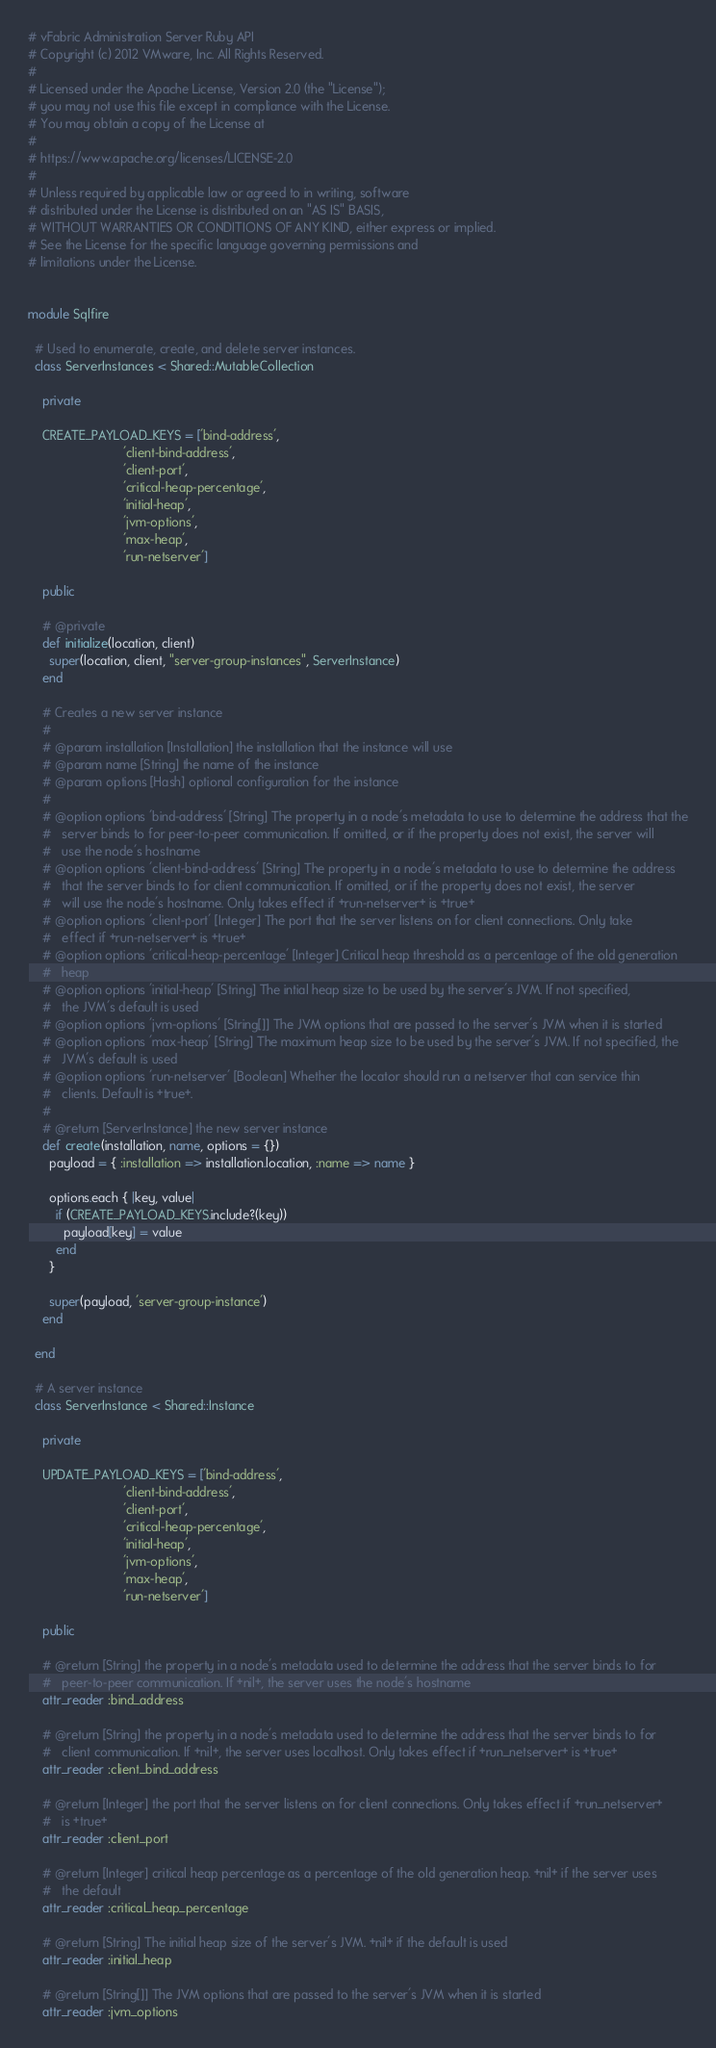<code> <loc_0><loc_0><loc_500><loc_500><_Ruby_># vFabric Administration Server Ruby API
# Copyright (c) 2012 VMware, Inc. All Rights Reserved.
#
# Licensed under the Apache License, Version 2.0 (the "License");
# you may not use this file except in compliance with the License.
# You may obtain a copy of the License at
#
# https://www.apache.org/licenses/LICENSE-2.0
#
# Unless required by applicable law or agreed to in writing, software
# distributed under the License is distributed on an "AS IS" BASIS,
# WITHOUT WARRANTIES OR CONDITIONS OF ANY KIND, either express or implied.
# See the License for the specific language governing permissions and
# limitations under the License.


module Sqlfire

  # Used to enumerate, create, and delete server instances.
  class ServerInstances < Shared::MutableCollection

    private

    CREATE_PAYLOAD_KEYS = ['bind-address',
                           'client-bind-address',
                           'client-port',
                           'critical-heap-percentage',
                           'initial-heap',
                           'jvm-options',
                           'max-heap',
                           'run-netserver']

    public

    # @private
    def initialize(location, client)
      super(location, client, "server-group-instances", ServerInstance)
    end

    # Creates a new server instance
    #
    # @param installation [Installation] the installation that the instance will use
    # @param name [String] the name of the instance
    # @param options [Hash] optional configuration for the instance
    #
    # @option options 'bind-address' [String] The property in a node's metadata to use to determine the address that the
    #   server binds to for peer-to-peer communication. If omitted, or if the property does not exist, the server will
    #   use the node's hostname
    # @option options 'client-bind-address' [String] The property in a node's metadata to use to determine the address
    #   that the server binds to for client communication. If omitted, or if the property does not exist, the server
    #   will use the node's hostname. Only takes effect if +run-netserver+ is +true+
    # @option options 'client-port' [Integer] The port that the server listens on for client connections. Only take
    #   effect if +run-netserver+ is +true+
    # @option options 'critical-heap-percentage' [Integer] Critical heap threshold as a percentage of the old generation
    #   heap
    # @option options 'initial-heap' [String] The intial heap size to be used by the server's JVM. If not specified,
    #   the JVM's default is used
    # @option options 'jvm-options' [String[]] The JVM options that are passed to the server's JVM when it is started
    # @option options 'max-heap' [String] The maximum heap size to be used by the server's JVM. If not specified, the
    #   JVM's default is used
    # @option options 'run-netserver' [Boolean] Whether the locator should run a netserver that can service thin
    #   clients. Default is +true+.
    #
    # @return [ServerInstance] the new server instance
    def create(installation, name, options = {})
      payload = { :installation => installation.location, :name => name }

      options.each { |key, value|
        if (CREATE_PAYLOAD_KEYS.include?(key))
          payload[key] = value
        end
      }

      super(payload, 'server-group-instance')
    end

  end

  # A server instance
  class ServerInstance < Shared::Instance

    private

    UPDATE_PAYLOAD_KEYS = ['bind-address',
                           'client-bind-address',
                           'client-port',
                           'critical-heap-percentage',
                           'initial-heap',
                           'jvm-options',
                           'max-heap',
                           'run-netserver']

    public

    # @return [String] the property in a node's metadata used to determine the address that the server binds to for
    #   peer-to-peer communication. If +nil+, the server uses the node's hostname
    attr_reader :bind_address

    # @return [String] the property in a node's metadata used to determine the address that the server binds to for
    #   client communication. If +nil+, the server uses localhost. Only takes effect if +run_netserver+ is +true+
    attr_reader :client_bind_address

    # @return [Integer] the port that the server listens on for client connections. Only takes effect if +run_netserver+
    #   is +true+
    attr_reader :client_port

    # @return [Integer] critical heap percentage as a percentage of the old generation heap. +nil+ if the server uses
    #   the default
    attr_reader :critical_heap_percentage

    # @return [String] The initial heap size of the server's JVM. +nil+ if the default is used
    attr_reader :initial_heap

    # @return [String[]] The JVM options that are passed to the server's JVM when it is started
    attr_reader :jvm_options
</code> 